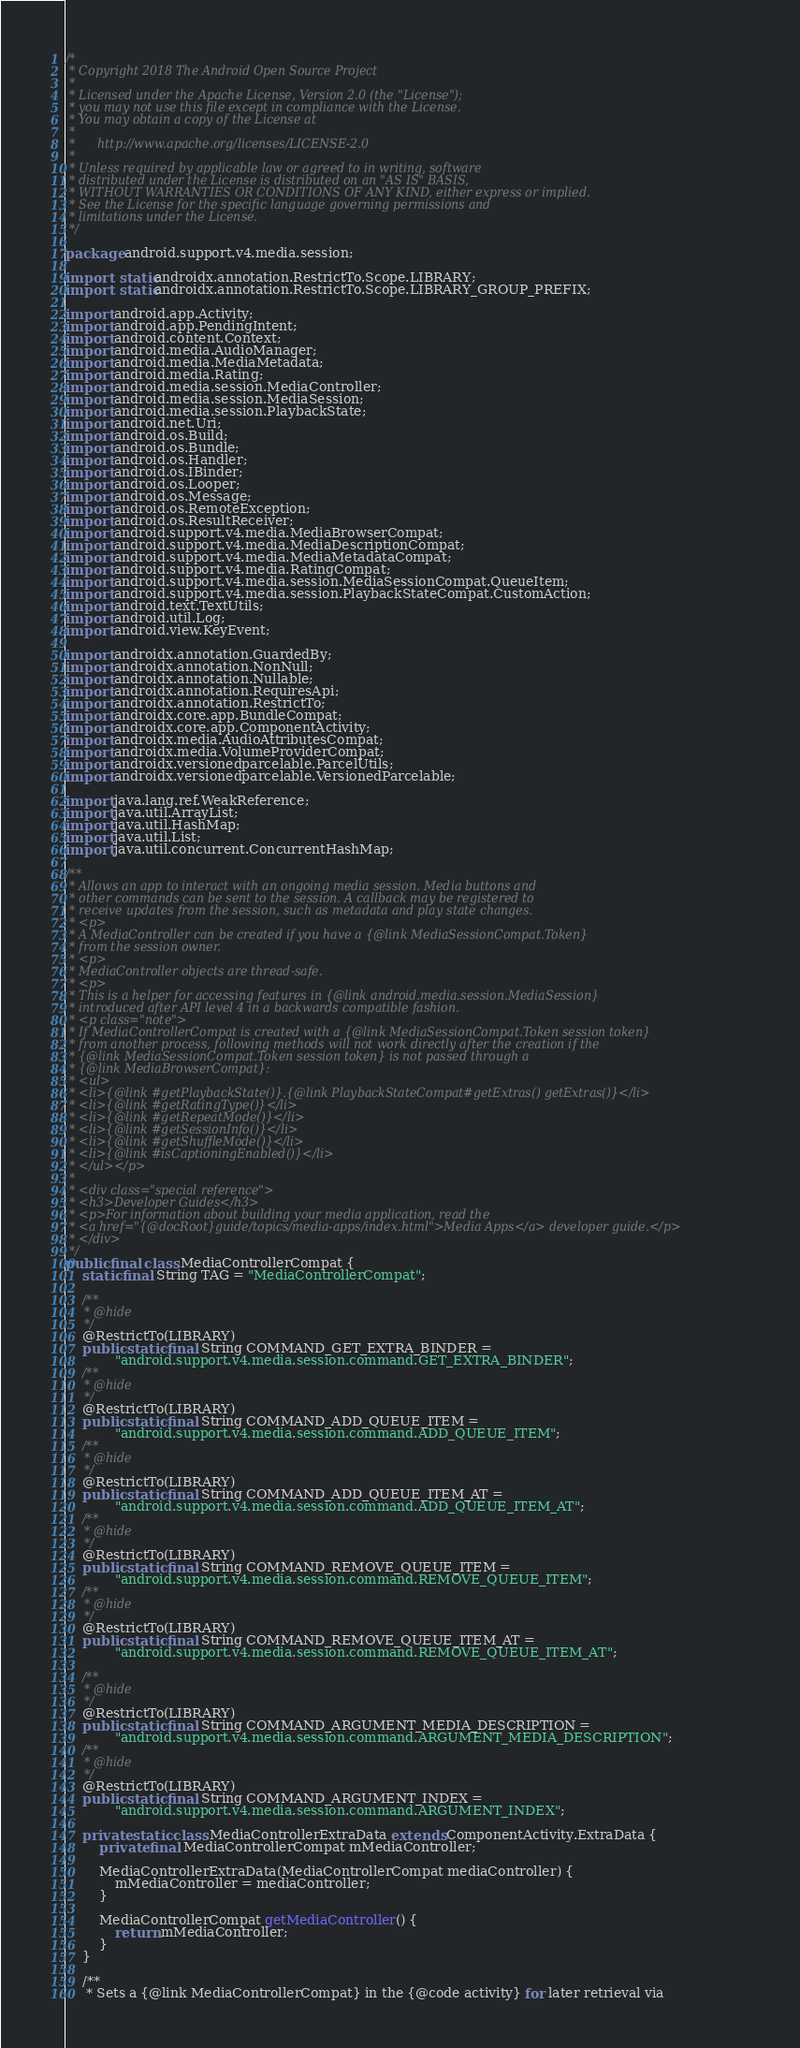<code> <loc_0><loc_0><loc_500><loc_500><_Java_>/*
 * Copyright 2018 The Android Open Source Project
 *
 * Licensed under the Apache License, Version 2.0 (the "License");
 * you may not use this file except in compliance with the License.
 * You may obtain a copy of the License at
 *
 *      http://www.apache.org/licenses/LICENSE-2.0
 *
 * Unless required by applicable law or agreed to in writing, software
 * distributed under the License is distributed on an "AS IS" BASIS,
 * WITHOUT WARRANTIES OR CONDITIONS OF ANY KIND, either express or implied.
 * See the License for the specific language governing permissions and
 * limitations under the License.
 */

package android.support.v4.media.session;

import static androidx.annotation.RestrictTo.Scope.LIBRARY;
import static androidx.annotation.RestrictTo.Scope.LIBRARY_GROUP_PREFIX;

import android.app.Activity;
import android.app.PendingIntent;
import android.content.Context;
import android.media.AudioManager;
import android.media.MediaMetadata;
import android.media.Rating;
import android.media.session.MediaController;
import android.media.session.MediaSession;
import android.media.session.PlaybackState;
import android.net.Uri;
import android.os.Build;
import android.os.Bundle;
import android.os.Handler;
import android.os.IBinder;
import android.os.Looper;
import android.os.Message;
import android.os.RemoteException;
import android.os.ResultReceiver;
import android.support.v4.media.MediaBrowserCompat;
import android.support.v4.media.MediaDescriptionCompat;
import android.support.v4.media.MediaMetadataCompat;
import android.support.v4.media.RatingCompat;
import android.support.v4.media.session.MediaSessionCompat.QueueItem;
import android.support.v4.media.session.PlaybackStateCompat.CustomAction;
import android.text.TextUtils;
import android.util.Log;
import android.view.KeyEvent;

import androidx.annotation.GuardedBy;
import androidx.annotation.NonNull;
import androidx.annotation.Nullable;
import androidx.annotation.RequiresApi;
import androidx.annotation.RestrictTo;
import androidx.core.app.BundleCompat;
import androidx.core.app.ComponentActivity;
import androidx.media.AudioAttributesCompat;
import androidx.media.VolumeProviderCompat;
import androidx.versionedparcelable.ParcelUtils;
import androidx.versionedparcelable.VersionedParcelable;

import java.lang.ref.WeakReference;
import java.util.ArrayList;
import java.util.HashMap;
import java.util.List;
import java.util.concurrent.ConcurrentHashMap;

/**
 * Allows an app to interact with an ongoing media session. Media buttons and
 * other commands can be sent to the session. A callback may be registered to
 * receive updates from the session, such as metadata and play state changes.
 * <p>
 * A MediaController can be created if you have a {@link MediaSessionCompat.Token}
 * from the session owner.
 * <p>
 * MediaController objects are thread-safe.
 * <p>
 * This is a helper for accessing features in {@link android.media.session.MediaSession}
 * introduced after API level 4 in a backwards compatible fashion.
 * <p class="note">
 * If MediaControllerCompat is created with a {@link MediaSessionCompat.Token session token}
 * from another process, following methods will not work directly after the creation if the
 * {@link MediaSessionCompat.Token session token} is not passed through a
 * {@link MediaBrowserCompat}:
 * <ul>
 * <li>{@link #getPlaybackState()}.{@link PlaybackStateCompat#getExtras() getExtras()}</li>
 * <li>{@link #getRatingType()}</li>
 * <li>{@link #getRepeatMode()}</li>
 * <li>{@link #getSessionInfo()}</li>
 * <li>{@link #getShuffleMode()}</li>
 * <li>{@link #isCaptioningEnabled()}</li>
 * </ul></p>
 *
 * <div class="special reference">
 * <h3>Developer Guides</h3>
 * <p>For information about building your media application, read the
 * <a href="{@docRoot}guide/topics/media-apps/index.html">Media Apps</a> developer guide.</p>
 * </div>
 */
public final class MediaControllerCompat {
    static final String TAG = "MediaControllerCompat";

    /**
     * @hide
     */
    @RestrictTo(LIBRARY)
    public static final String COMMAND_GET_EXTRA_BINDER =
            "android.support.v4.media.session.command.GET_EXTRA_BINDER";
    /**
     * @hide
     */
    @RestrictTo(LIBRARY)
    public static final String COMMAND_ADD_QUEUE_ITEM =
            "android.support.v4.media.session.command.ADD_QUEUE_ITEM";
    /**
     * @hide
     */
    @RestrictTo(LIBRARY)
    public static final String COMMAND_ADD_QUEUE_ITEM_AT =
            "android.support.v4.media.session.command.ADD_QUEUE_ITEM_AT";
    /**
     * @hide
     */
    @RestrictTo(LIBRARY)
    public static final String COMMAND_REMOVE_QUEUE_ITEM =
            "android.support.v4.media.session.command.REMOVE_QUEUE_ITEM";
    /**
     * @hide
     */
    @RestrictTo(LIBRARY)
    public static final String COMMAND_REMOVE_QUEUE_ITEM_AT =
            "android.support.v4.media.session.command.REMOVE_QUEUE_ITEM_AT";

    /**
     * @hide
     */
    @RestrictTo(LIBRARY)
    public static final String COMMAND_ARGUMENT_MEDIA_DESCRIPTION =
            "android.support.v4.media.session.command.ARGUMENT_MEDIA_DESCRIPTION";
    /**
     * @hide
     */
    @RestrictTo(LIBRARY)
    public static final String COMMAND_ARGUMENT_INDEX =
            "android.support.v4.media.session.command.ARGUMENT_INDEX";

    private static class MediaControllerExtraData extends ComponentActivity.ExtraData {
        private final MediaControllerCompat mMediaController;

        MediaControllerExtraData(MediaControllerCompat mediaController) {
            mMediaController = mediaController;
        }

        MediaControllerCompat getMediaController() {
            return mMediaController;
        }
    }

    /**
     * Sets a {@link MediaControllerCompat} in the {@code activity} for later retrieval via</code> 